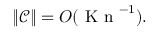Convert formula to latex. <formula><loc_0><loc_0><loc_500><loc_500>\| \mathcal { C } \| = O ( { K n } ^ { - 1 } ) .</formula> 